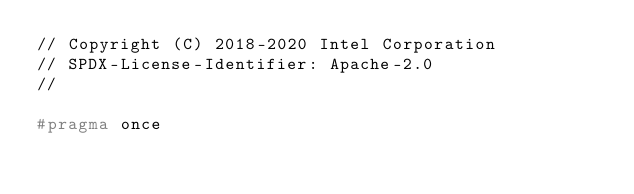Convert code to text. <code><loc_0><loc_0><loc_500><loc_500><_C++_>// Copyright (C) 2018-2020 Intel Corporation
// SPDX-License-Identifier: Apache-2.0
//

#pragma once
</code> 